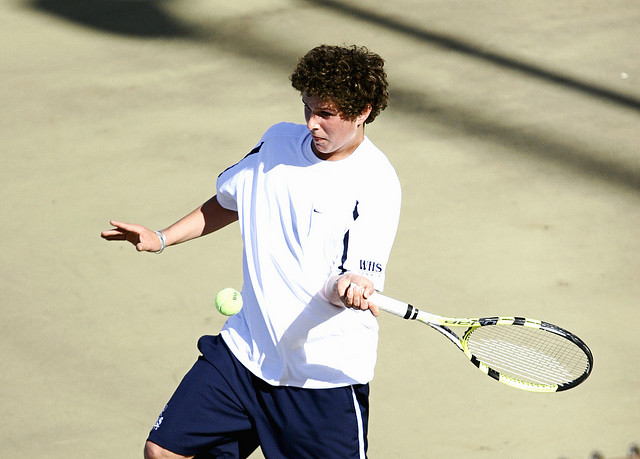Please extract the text content from this image. WHS 